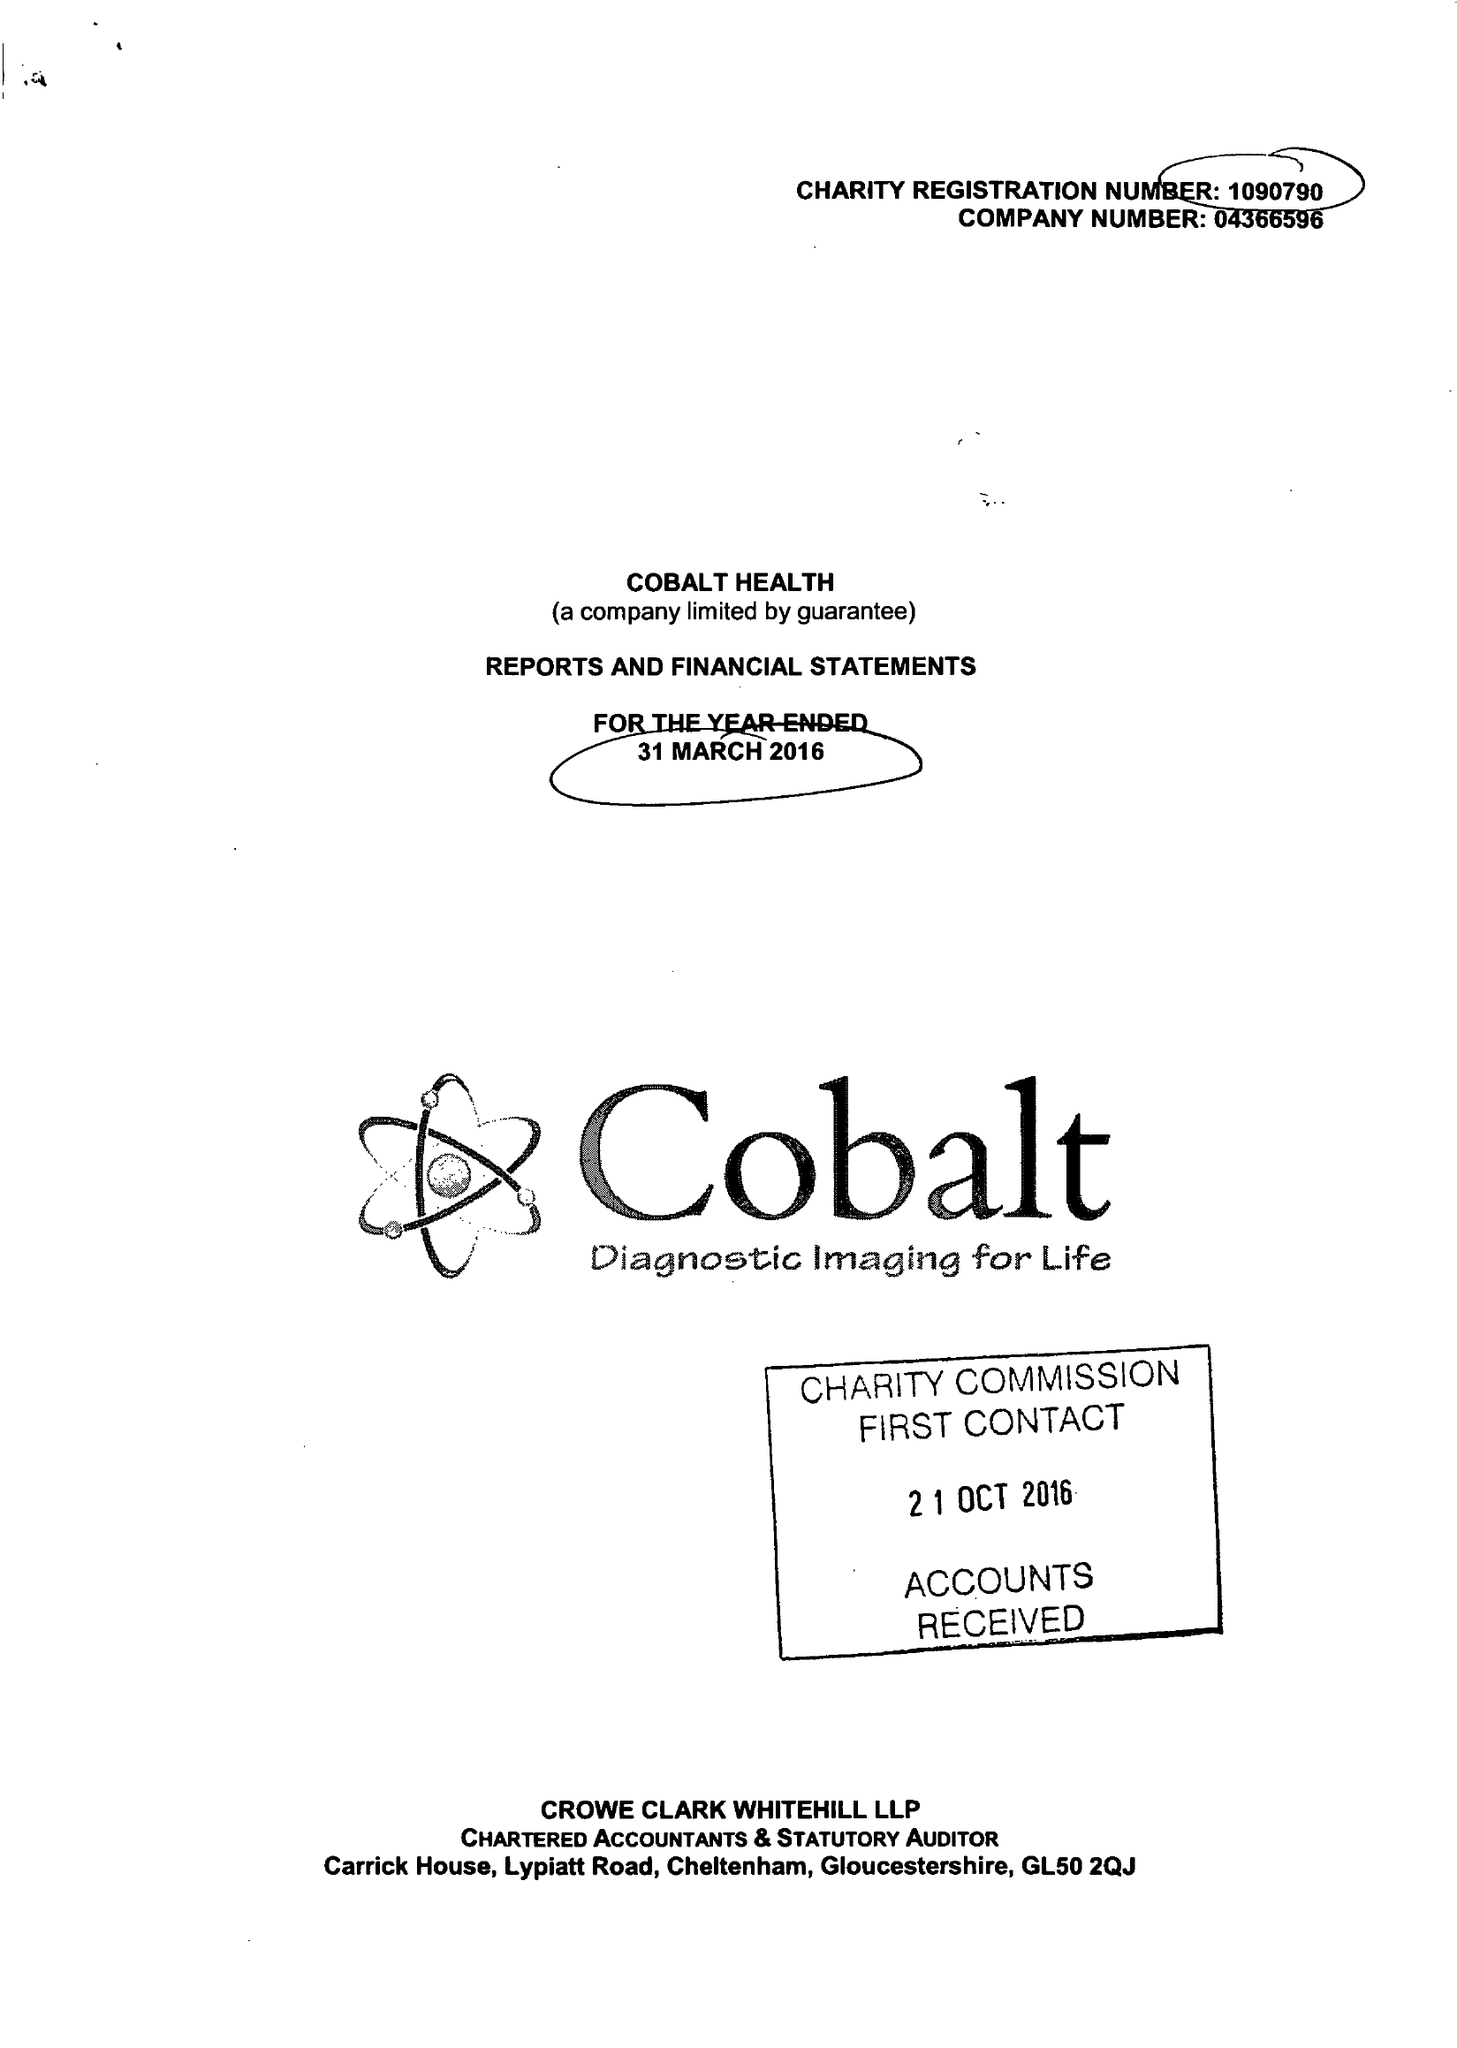What is the value for the address__street_line?
Answer the question using a single word or phrase. THIRLESTAINE ROAD 